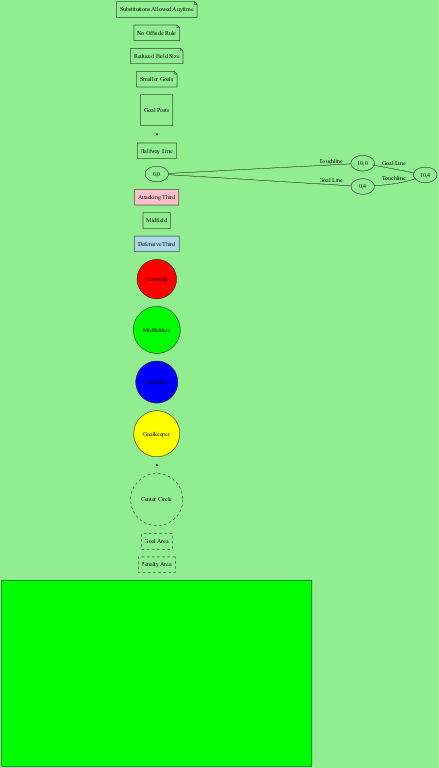What is the shape of the soccer field? The diagram specifies that the soccer field is a rectangle, indicating its overall shape and dimensions.
Answer: Rectangle How many key areas are shown in the diagram? By counting the nodes labeled under key areas, we find there are four key areas indicated in the diagram.
Answer: Four Which player position is represented at the leftmost part of the field? The leftmost node represents the Goalkeeper, which is positioned in front of the goal on the field.
Answer: Goalkeeper What are the colors of the Defenders' positions? The node representing Defenders shows they are filled with blue color, indicating their specific role and position on the field.
Answer: Blue What defines the Attacking Third zone? The Attacking Third zone is represented on the diagram as a rectangular area filled with pink, showing the section of the field designated for offensive plays.
Answer: Pink How many types of player positions are represented? There are four distinct player positions indicated in the diagram, providing a clear understanding of roles on the soccer field.
Answer: Four What rule is mentioned related to substitutions? The note section states that substitutions are allowed anytime, which alters how game play can proceed in this youth league.
Answer: Substitutions Allowed Anytime Where can the Penalty Spot be found? The Penalty Spot is shown on the diagram and is positioned inside the Penalty Area, specifically where penalty kicks are taken.
Answer: Penalty Area What is the main color used for the entire soccer field representation? The entire soccer field is depicted using a green fill color, which represents the grass or playing surface of a soccer field.
Answer: Green 